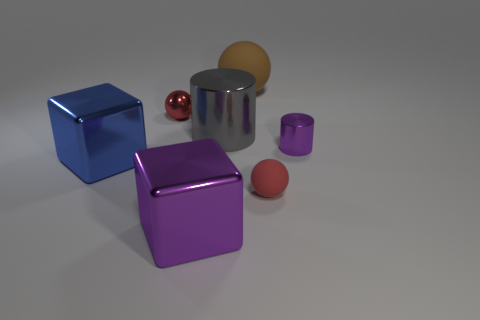Does the big blue thing have the same shape as the large purple shiny object?
Provide a short and direct response. Yes. How many balls are both in front of the big gray shiny thing and behind the tiny red metal object?
Offer a terse response. 0. Are there the same number of large brown balls to the left of the large blue shiny block and small metallic cylinders that are behind the big sphere?
Provide a short and direct response. Yes. There is a brown rubber object to the right of the metallic ball; is it the same size as the matte sphere that is in front of the large metallic cylinder?
Your answer should be compact. No. What material is the object that is in front of the big gray metal object and to the left of the big purple cube?
Offer a terse response. Metal. Is the number of big purple rubber balls less than the number of tiny rubber objects?
Give a very brief answer. Yes. What is the size of the block right of the red object that is behind the blue metallic block?
Your answer should be compact. Large. What shape is the purple object right of the matte object in front of the purple object on the right side of the large sphere?
Provide a short and direct response. Cylinder. There is a small sphere that is the same material as the gray cylinder; what is its color?
Make the answer very short. Red. What is the color of the rubber thing that is behind the large cube that is to the left of the tiny red sphere that is to the left of the gray shiny cylinder?
Your answer should be very brief. Brown. 